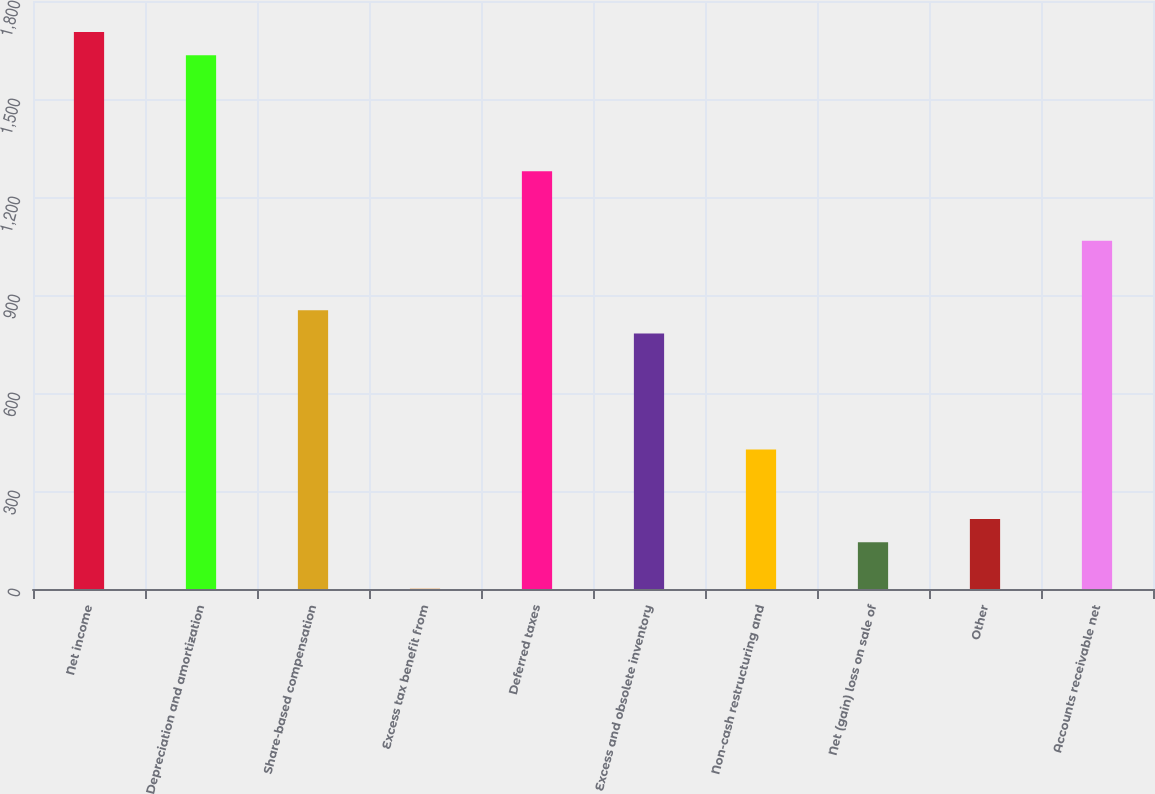<chart> <loc_0><loc_0><loc_500><loc_500><bar_chart><fcel>Net income<fcel>Depreciation and amortization<fcel>Share-based compensation<fcel>Excess tax benefit from<fcel>Deferred taxes<fcel>Excess and obsolete inventory<fcel>Non-cash restructuring and<fcel>Net (gain) loss on sale of<fcel>Other<fcel>Accounts receivable net<nl><fcel>1705<fcel>1634<fcel>853<fcel>1<fcel>1279<fcel>782<fcel>427<fcel>143<fcel>214<fcel>1066<nl></chart> 